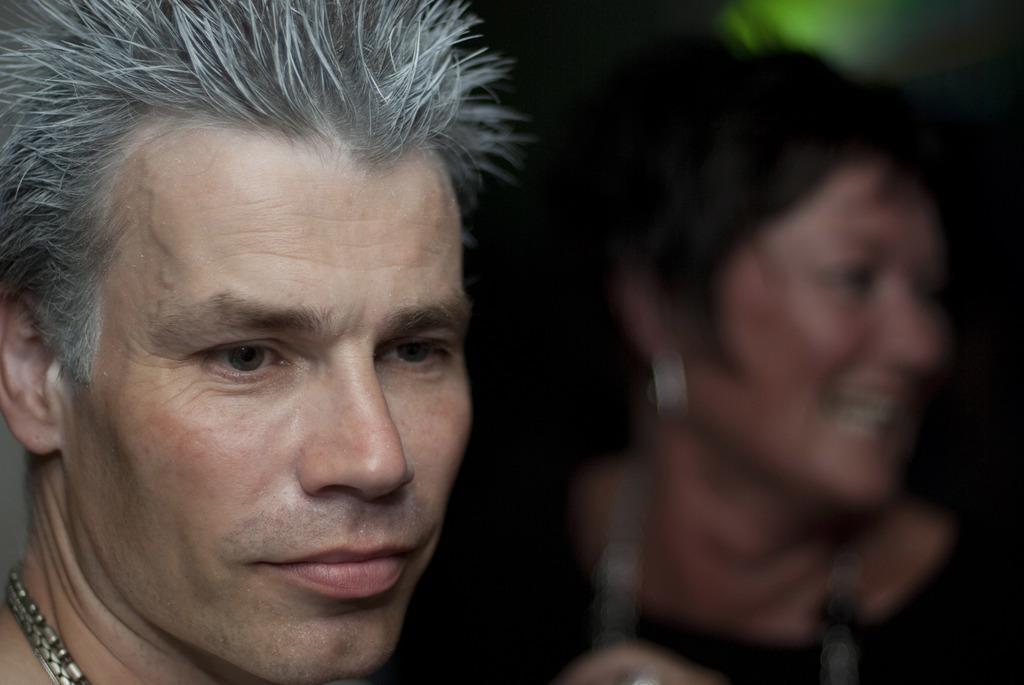Please provide a concise description of this image. In the image in the center, we can see two persons. They are smiling, which we can see on their faces. 